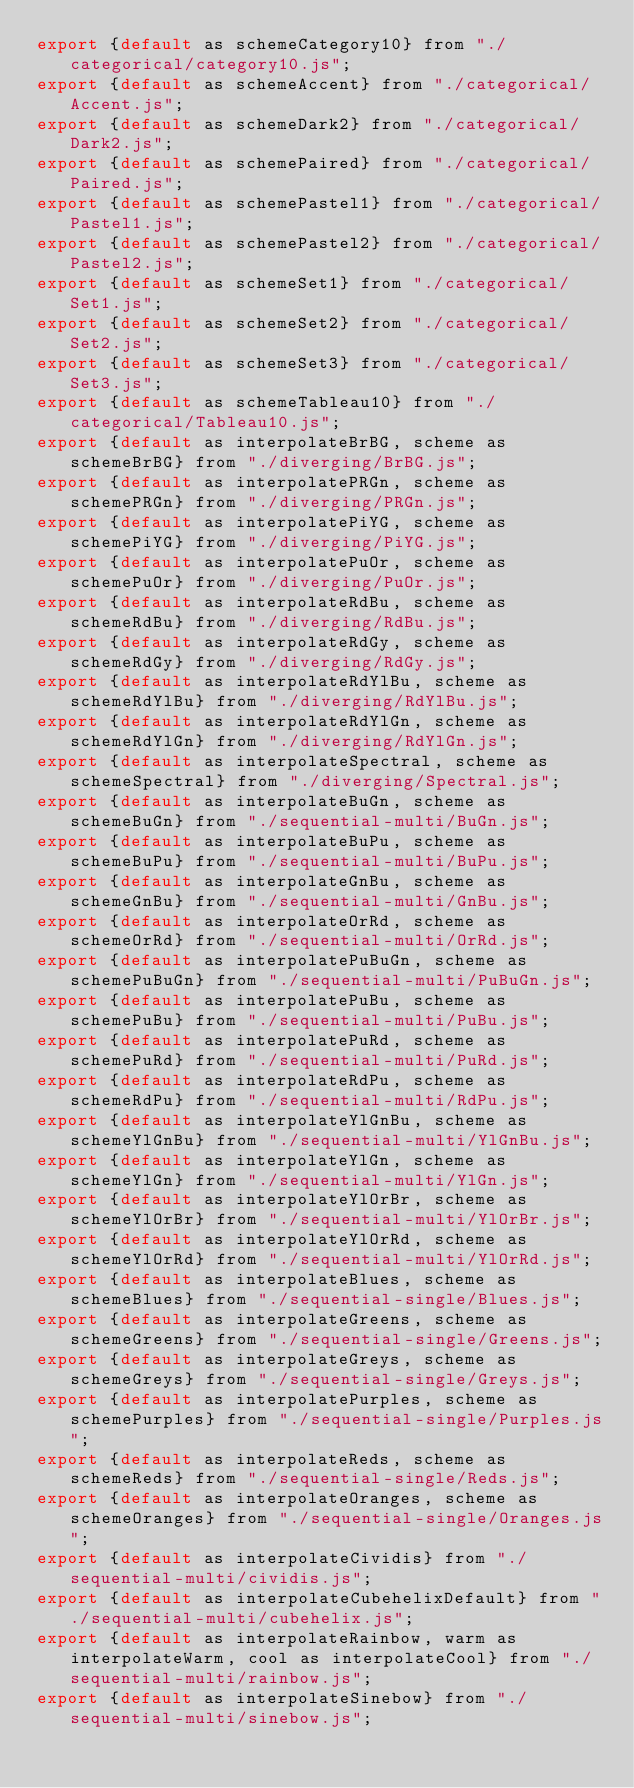Convert code to text. <code><loc_0><loc_0><loc_500><loc_500><_JavaScript_>export {default as schemeCategory10} from "./categorical/category10.js";
export {default as schemeAccent} from "./categorical/Accent.js";
export {default as schemeDark2} from "./categorical/Dark2.js";
export {default as schemePaired} from "./categorical/Paired.js";
export {default as schemePastel1} from "./categorical/Pastel1.js";
export {default as schemePastel2} from "./categorical/Pastel2.js";
export {default as schemeSet1} from "./categorical/Set1.js";
export {default as schemeSet2} from "./categorical/Set2.js";
export {default as schemeSet3} from "./categorical/Set3.js";
export {default as schemeTableau10} from "./categorical/Tableau10.js";
export {default as interpolateBrBG, scheme as schemeBrBG} from "./diverging/BrBG.js";
export {default as interpolatePRGn, scheme as schemePRGn} from "./diverging/PRGn.js";
export {default as interpolatePiYG, scheme as schemePiYG} from "./diverging/PiYG.js";
export {default as interpolatePuOr, scheme as schemePuOr} from "./diverging/PuOr.js";
export {default as interpolateRdBu, scheme as schemeRdBu} from "./diverging/RdBu.js";
export {default as interpolateRdGy, scheme as schemeRdGy} from "./diverging/RdGy.js";
export {default as interpolateRdYlBu, scheme as schemeRdYlBu} from "./diverging/RdYlBu.js";
export {default as interpolateRdYlGn, scheme as schemeRdYlGn} from "./diverging/RdYlGn.js";
export {default as interpolateSpectral, scheme as schemeSpectral} from "./diverging/Spectral.js";
export {default as interpolateBuGn, scheme as schemeBuGn} from "./sequential-multi/BuGn.js";
export {default as interpolateBuPu, scheme as schemeBuPu} from "./sequential-multi/BuPu.js";
export {default as interpolateGnBu, scheme as schemeGnBu} from "./sequential-multi/GnBu.js";
export {default as interpolateOrRd, scheme as schemeOrRd} from "./sequential-multi/OrRd.js";
export {default as interpolatePuBuGn, scheme as schemePuBuGn} from "./sequential-multi/PuBuGn.js";
export {default as interpolatePuBu, scheme as schemePuBu} from "./sequential-multi/PuBu.js";
export {default as interpolatePuRd, scheme as schemePuRd} from "./sequential-multi/PuRd.js";
export {default as interpolateRdPu, scheme as schemeRdPu} from "./sequential-multi/RdPu.js";
export {default as interpolateYlGnBu, scheme as schemeYlGnBu} from "./sequential-multi/YlGnBu.js";
export {default as interpolateYlGn, scheme as schemeYlGn} from "./sequential-multi/YlGn.js";
export {default as interpolateYlOrBr, scheme as schemeYlOrBr} from "./sequential-multi/YlOrBr.js";
export {default as interpolateYlOrRd, scheme as schemeYlOrRd} from "./sequential-multi/YlOrRd.js";
export {default as interpolateBlues, scheme as schemeBlues} from "./sequential-single/Blues.js";
export {default as interpolateGreens, scheme as schemeGreens} from "./sequential-single/Greens.js";
export {default as interpolateGreys, scheme as schemeGreys} from "./sequential-single/Greys.js";
export {default as interpolatePurples, scheme as schemePurples} from "./sequential-single/Purples.js";
export {default as interpolateReds, scheme as schemeReds} from "./sequential-single/Reds.js";
export {default as interpolateOranges, scheme as schemeOranges} from "./sequential-single/Oranges.js";
export {default as interpolateCividis} from "./sequential-multi/cividis.js";
export {default as interpolateCubehelixDefault} from "./sequential-multi/cubehelix.js";
export {default as interpolateRainbow, warm as interpolateWarm, cool as interpolateCool} from "./sequential-multi/rainbow.js";
export {default as interpolateSinebow} from "./sequential-multi/sinebow.js";</code> 